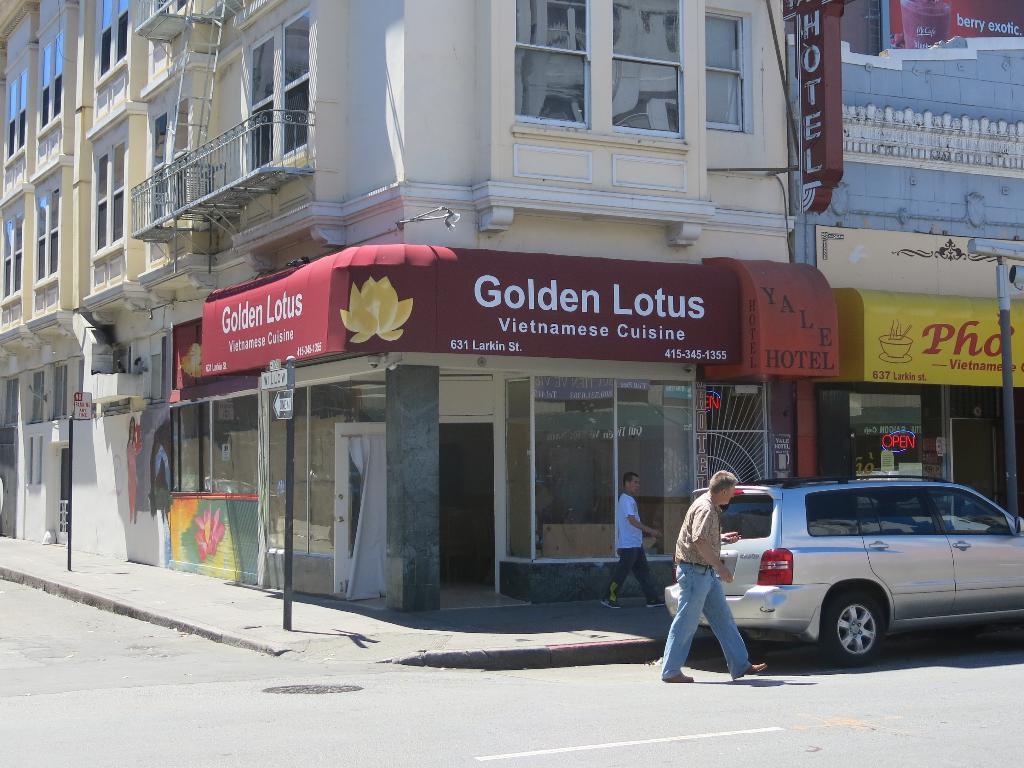Can you describe this image briefly? In the image there are two persons walking in front of the building on the road, there is a car on the right side. 